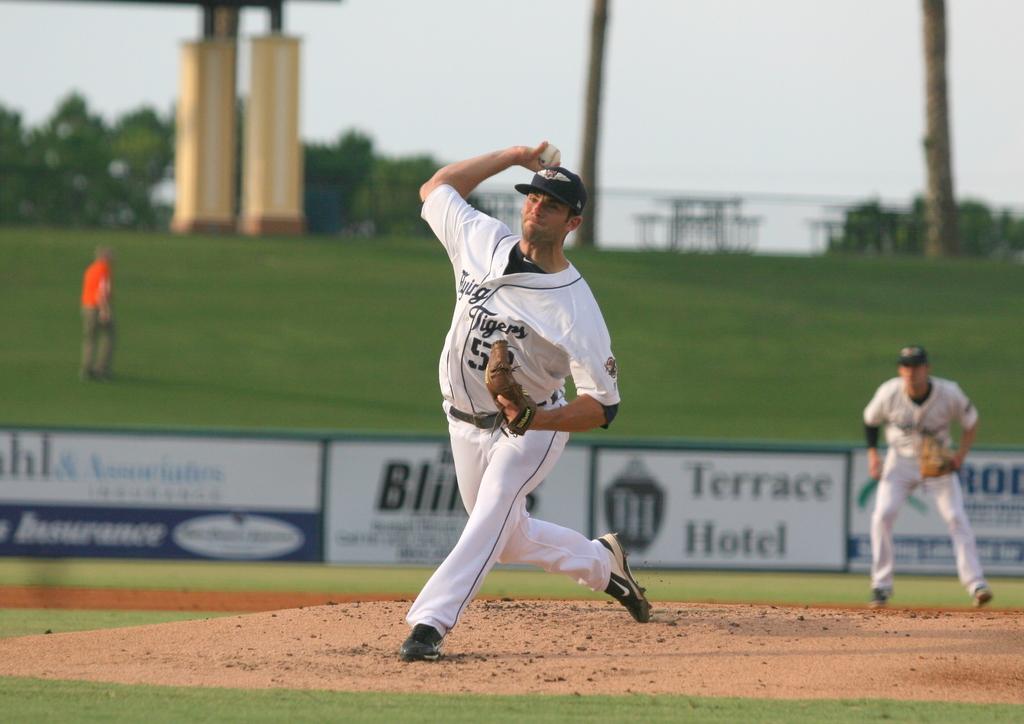Who are the advertisers?
Your response must be concise. Terrace hotel. What is the name of the team on the jersey?
Your answer should be compact. Tigers. 